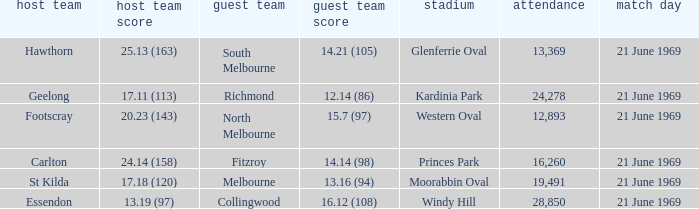When did an away team score 15.7 (97)? 21 June 1969. 